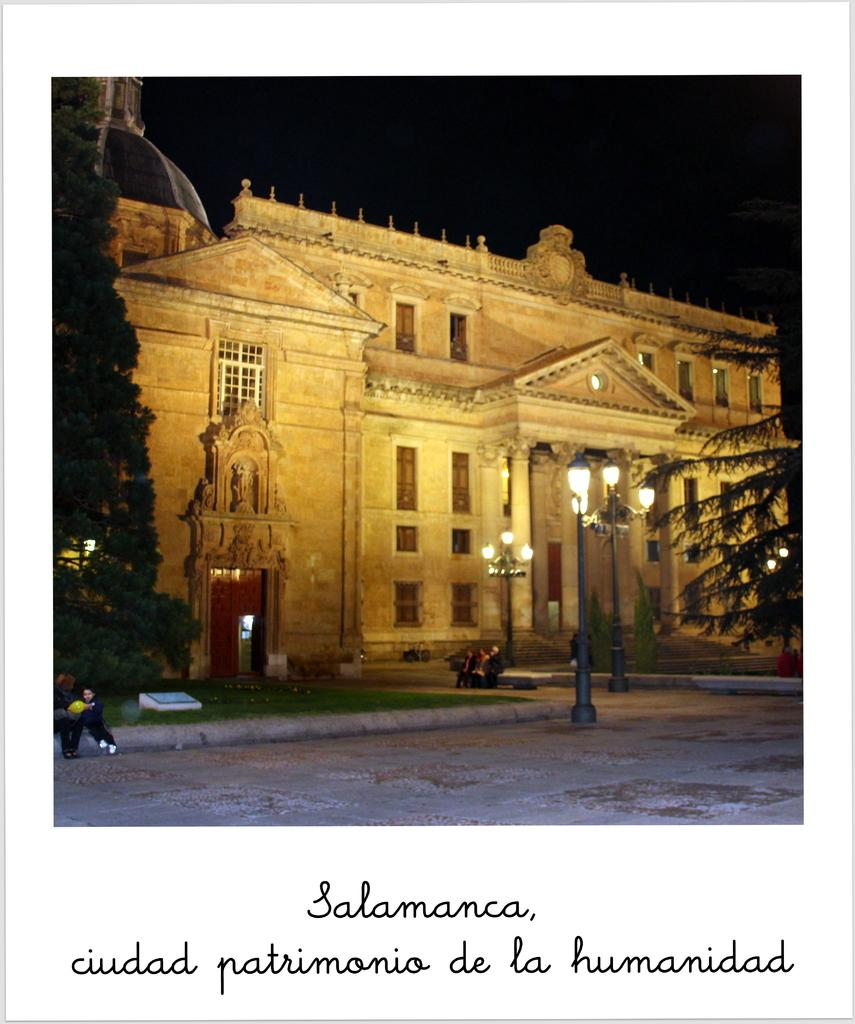What is present in the foreground of the image? There is text in the foreground of the image. What type of surface is visible in the image? There is pavement in the image. What structures can be seen in the image? There are light poles in the image. What type of vegetation is present in the image? There is grass in the image. What are the people in the image doing? There are persons sitting in the image. What other natural elements can be seen in the image? There are trees in the image. What type of man-made structure is visible in the image? There is a building in the image. How would you describe the sky in the image? The sky is dark in the image. What type of disease is being treated in the image? There is no indication of a disease or treatment in the image. What mode of transportation is being used by the persons in the image? There is no carriage or any other mode of transportation visible in the image; the persons are sitting. 